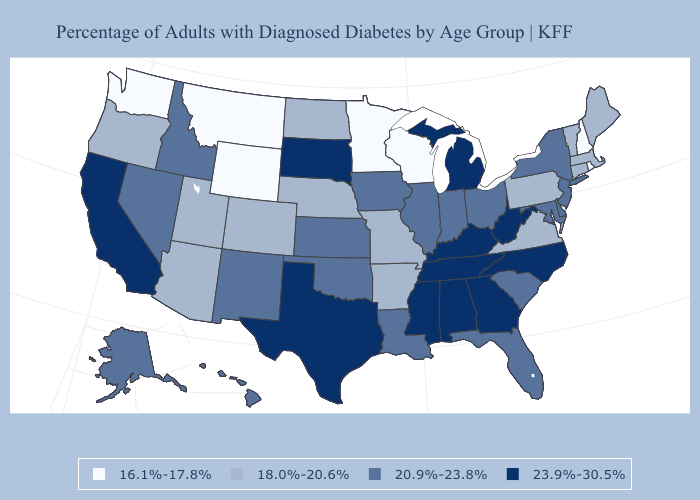What is the value of New York?
Give a very brief answer. 20.9%-23.8%. Does Oklahoma have the lowest value in the South?
Give a very brief answer. No. What is the lowest value in states that border Nevada?
Be succinct. 18.0%-20.6%. Among the states that border Louisiana , which have the highest value?
Concise answer only. Mississippi, Texas. Does Nevada have a higher value than Colorado?
Quick response, please. Yes. Name the states that have a value in the range 16.1%-17.8%?
Write a very short answer. Minnesota, Montana, New Hampshire, Rhode Island, Washington, Wisconsin, Wyoming. What is the value of Rhode Island?
Keep it brief. 16.1%-17.8%. What is the highest value in the USA?
Concise answer only. 23.9%-30.5%. Among the states that border Massachusetts , which have the lowest value?
Quick response, please. New Hampshire, Rhode Island. What is the lowest value in the MidWest?
Short answer required. 16.1%-17.8%. Does Ohio have a lower value than California?
Keep it brief. Yes. Name the states that have a value in the range 18.0%-20.6%?
Give a very brief answer. Arizona, Arkansas, Colorado, Connecticut, Maine, Massachusetts, Missouri, Nebraska, North Dakota, Oregon, Pennsylvania, Utah, Vermont, Virginia. What is the value of New Hampshire?
Keep it brief. 16.1%-17.8%. Does Idaho have the lowest value in the West?
Keep it brief. No. Among the states that border Wisconsin , which have the highest value?
Keep it brief. Michigan. 